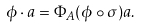<formula> <loc_0><loc_0><loc_500><loc_500>\phi \cdot a = \Phi _ { A } ( \phi \circ \sigma ) a .</formula> 